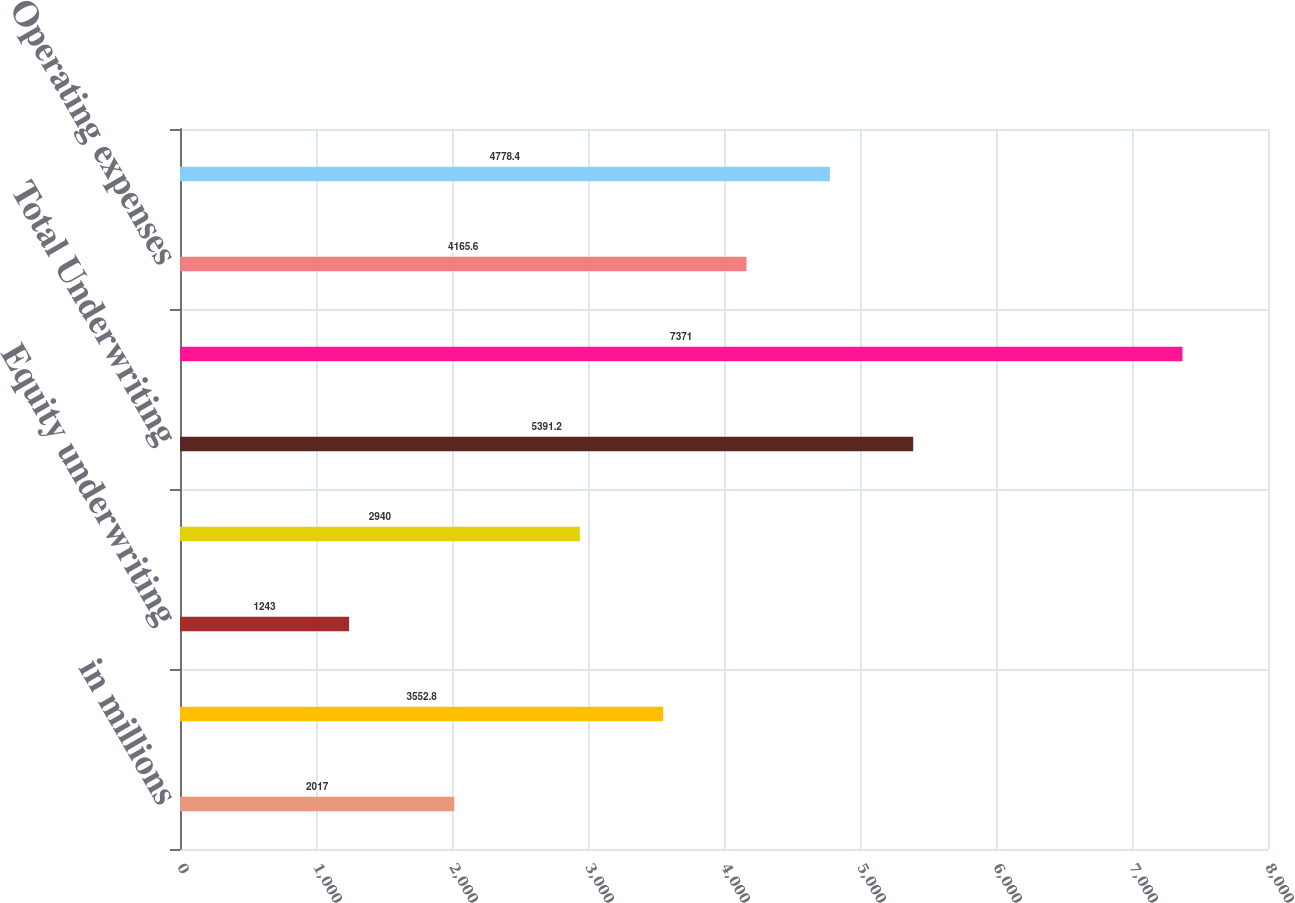Convert chart to OTSL. <chart><loc_0><loc_0><loc_500><loc_500><bar_chart><fcel>in millions<fcel>Financial Advisory<fcel>Equity underwriting<fcel>Debt underwriting<fcel>Total Underwriting<fcel>Total net revenues<fcel>Operating expenses<fcel>Pre-tax earnings<nl><fcel>2017<fcel>3552.8<fcel>1243<fcel>2940<fcel>5391.2<fcel>7371<fcel>4165.6<fcel>4778.4<nl></chart> 